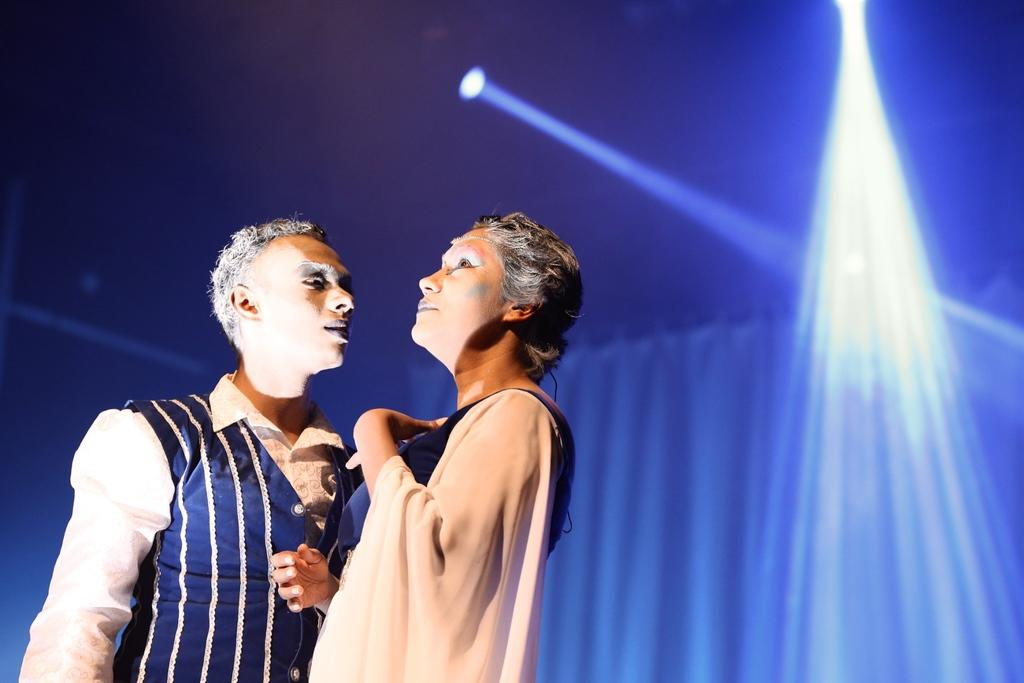How many people are in the image? There are two people in the foreground of the image. What can be seen in the background of the image? The background of the image has a blue color. What type of thrill can be seen in the image? There is no thrill present in the image; it features two people in the foreground and a blue background. What kind of beef is being cooked in the image? There is no beef or cooking activity present in the image. 